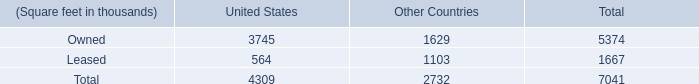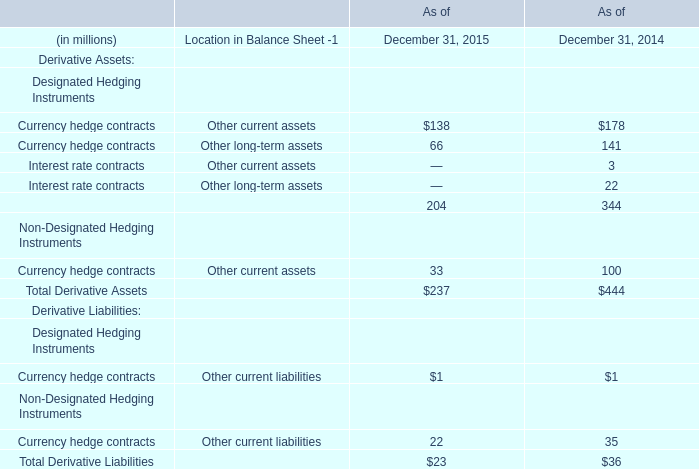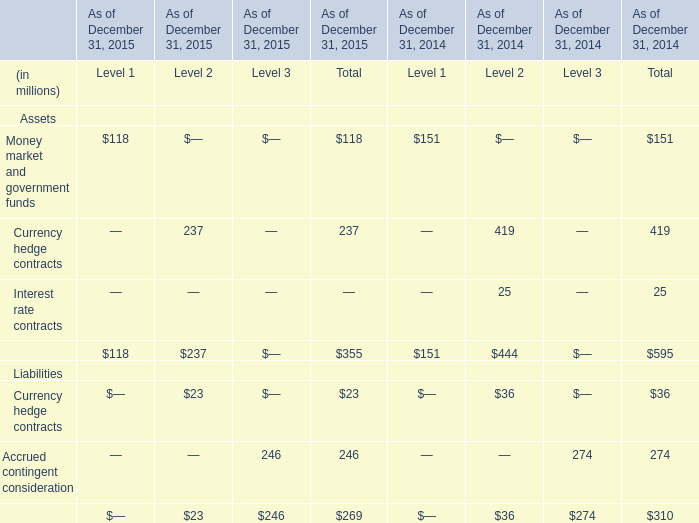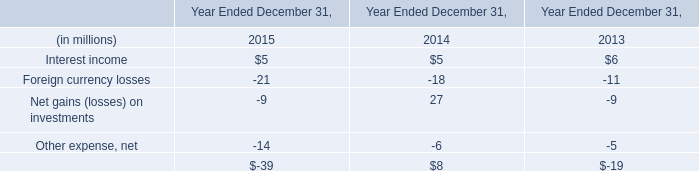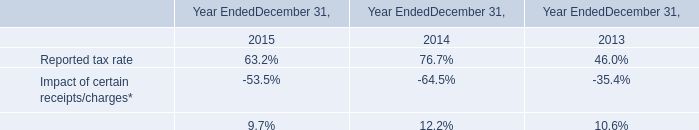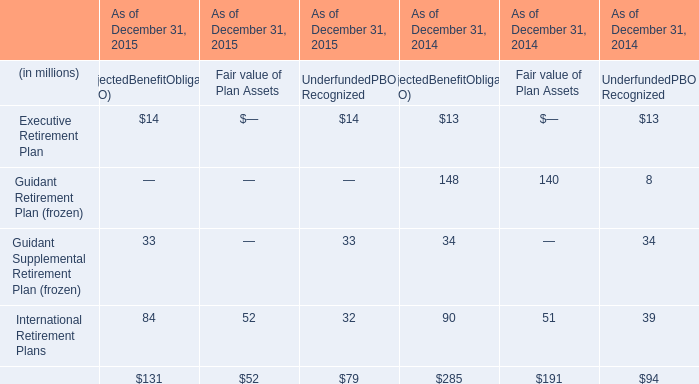What's the growth rate of Currency hedge contracts of Other current assets in 2015? 
Computations: ((138 - 178) / 178)
Answer: -0.22472. 